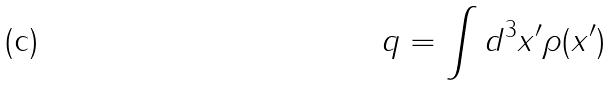<formula> <loc_0><loc_0><loc_500><loc_500>q = \int d ^ { 3 } x ^ { \prime } \rho ( x ^ { \prime } )</formula> 